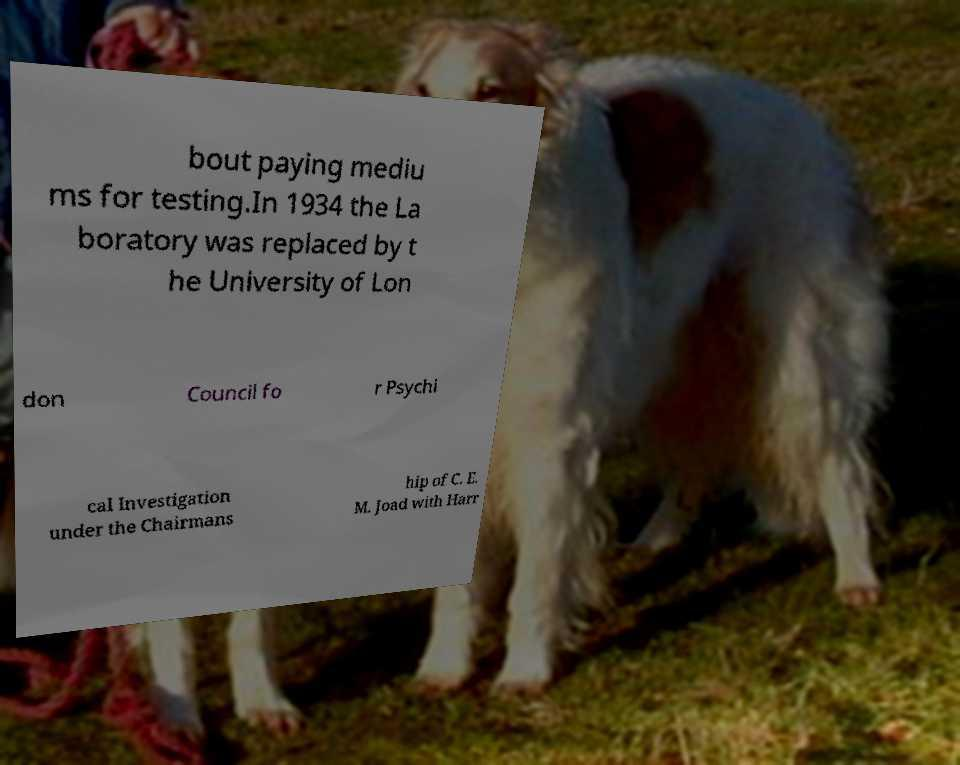I need the written content from this picture converted into text. Can you do that? bout paying mediu ms for testing.In 1934 the La boratory was replaced by t he University of Lon don Council fo r Psychi cal Investigation under the Chairmans hip of C. E. M. Joad with Harr 